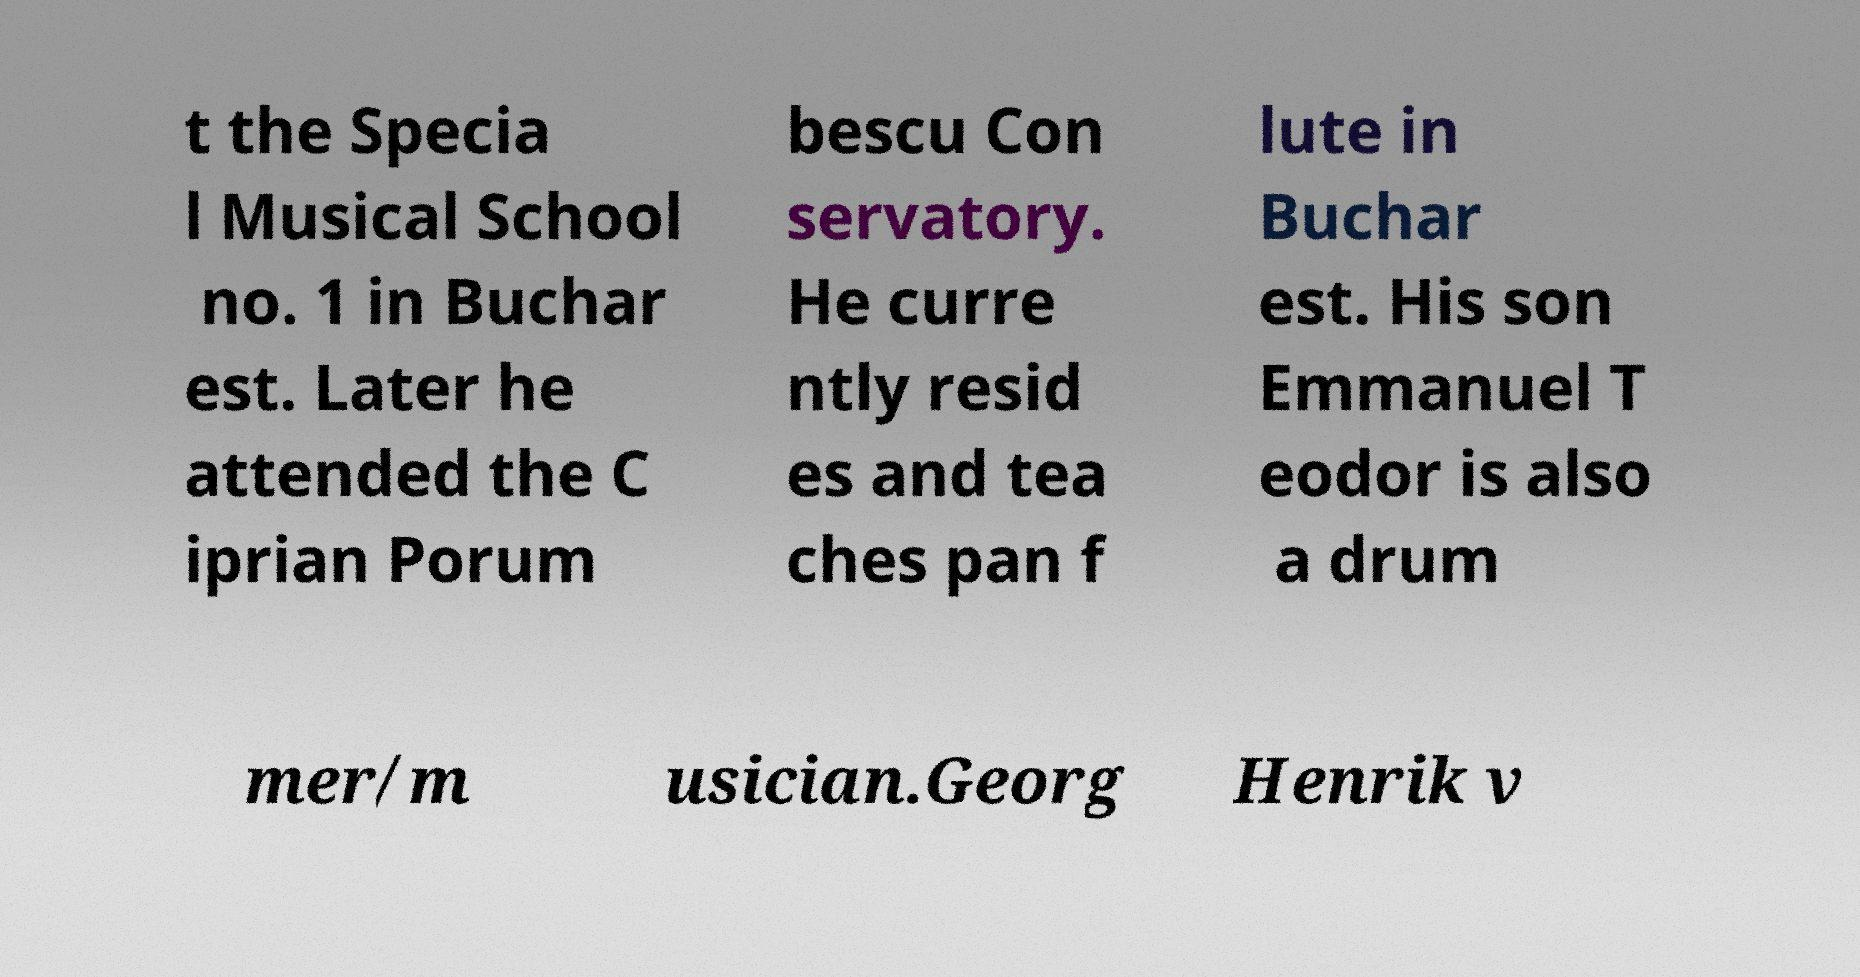Can you accurately transcribe the text from the provided image for me? t the Specia l Musical School no. 1 in Buchar est. Later he attended the C iprian Porum bescu Con servatory. He curre ntly resid es and tea ches pan f lute in Buchar est. His son Emmanuel T eodor is also a drum mer/m usician.Georg Henrik v 